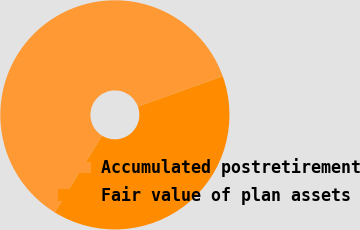<chart> <loc_0><loc_0><loc_500><loc_500><pie_chart><fcel>Accumulated postretirement<fcel>Fair value of plan assets<nl><fcel>60.71%<fcel>39.29%<nl></chart> 